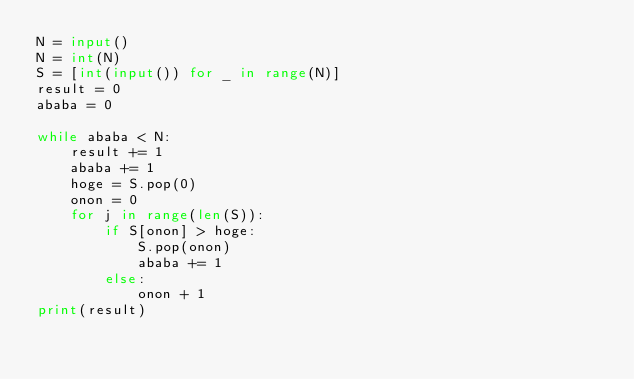Convert code to text. <code><loc_0><loc_0><loc_500><loc_500><_Python_>N = input()
N = int(N)
S = [int(input()) for _ in range(N)]
result = 0
ababa = 0

while ababa < N:
    result += 1
    ababa += 1
    hoge = S.pop(0)
    onon = 0
    for j in range(len(S)):
        if S[onon] > hoge:
            S.pop(onon)
            ababa += 1
        else:
            onon + 1
print(result)</code> 